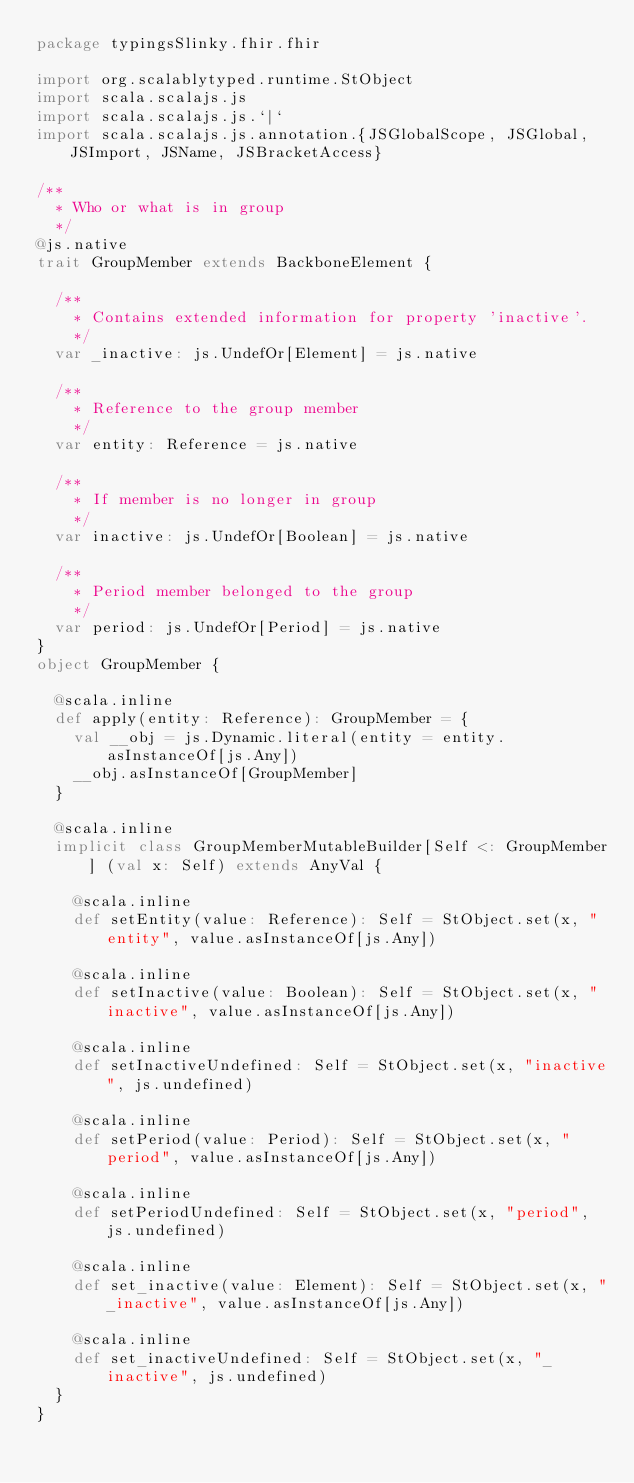Convert code to text. <code><loc_0><loc_0><loc_500><loc_500><_Scala_>package typingsSlinky.fhir.fhir

import org.scalablytyped.runtime.StObject
import scala.scalajs.js
import scala.scalajs.js.`|`
import scala.scalajs.js.annotation.{JSGlobalScope, JSGlobal, JSImport, JSName, JSBracketAccess}

/**
  * Who or what is in group
  */
@js.native
trait GroupMember extends BackboneElement {
  
  /**
    * Contains extended information for property 'inactive'.
    */
  var _inactive: js.UndefOr[Element] = js.native
  
  /**
    * Reference to the group member
    */
  var entity: Reference = js.native
  
  /**
    * If member is no longer in group
    */
  var inactive: js.UndefOr[Boolean] = js.native
  
  /**
    * Period member belonged to the group
    */
  var period: js.UndefOr[Period] = js.native
}
object GroupMember {
  
  @scala.inline
  def apply(entity: Reference): GroupMember = {
    val __obj = js.Dynamic.literal(entity = entity.asInstanceOf[js.Any])
    __obj.asInstanceOf[GroupMember]
  }
  
  @scala.inline
  implicit class GroupMemberMutableBuilder[Self <: GroupMember] (val x: Self) extends AnyVal {
    
    @scala.inline
    def setEntity(value: Reference): Self = StObject.set(x, "entity", value.asInstanceOf[js.Any])
    
    @scala.inline
    def setInactive(value: Boolean): Self = StObject.set(x, "inactive", value.asInstanceOf[js.Any])
    
    @scala.inline
    def setInactiveUndefined: Self = StObject.set(x, "inactive", js.undefined)
    
    @scala.inline
    def setPeriod(value: Period): Self = StObject.set(x, "period", value.asInstanceOf[js.Any])
    
    @scala.inline
    def setPeriodUndefined: Self = StObject.set(x, "period", js.undefined)
    
    @scala.inline
    def set_inactive(value: Element): Self = StObject.set(x, "_inactive", value.asInstanceOf[js.Any])
    
    @scala.inline
    def set_inactiveUndefined: Self = StObject.set(x, "_inactive", js.undefined)
  }
}
</code> 